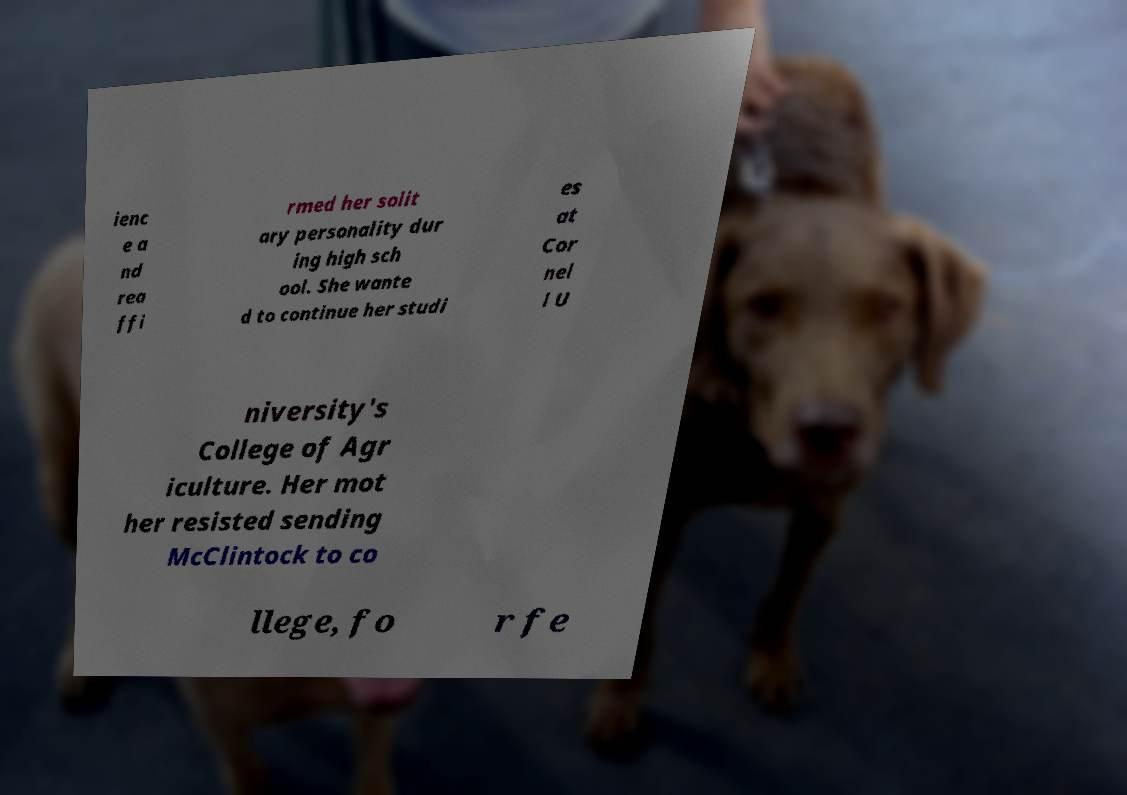I need the written content from this picture converted into text. Can you do that? ienc e a nd rea ffi rmed her solit ary personality dur ing high sch ool. She wante d to continue her studi es at Cor nel l U niversity's College of Agr iculture. Her mot her resisted sending McClintock to co llege, fo r fe 